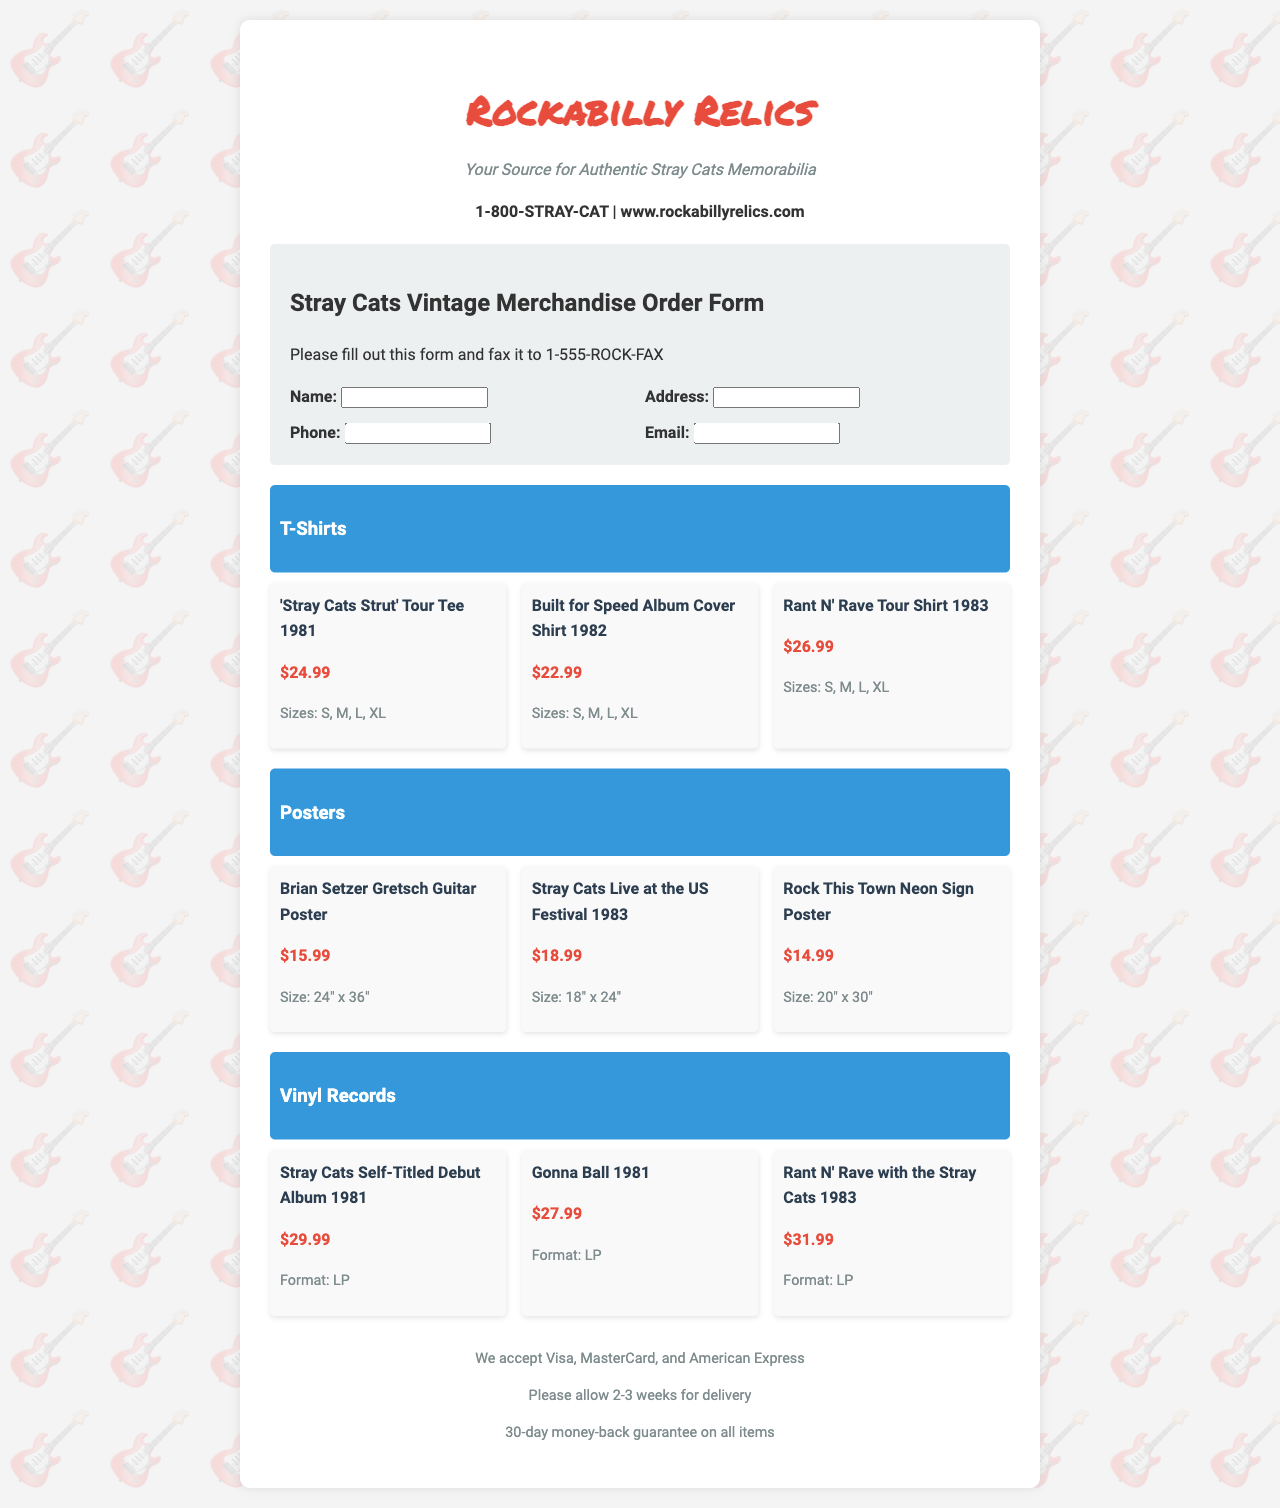What is the fax number to send the order form? The fax number is clearly stated in the document as 1-555-ROCK-FAX.
Answer: 1-555-ROCK-FAX How many types of merchandise are listed in the document? The document includes three categories of merchandise: T-Shirts, Posters, and Vinyl Records.
Answer: Three What is the price of the 'Stray Cats Strut' Tour Tee 1981? The price for the 'Stray Cats Strut' Tour Tee 1981 is listed as $24.99.
Answer: $24.99 What size options are available for the Built for Speed Album Cover Shirt? The shirt offers Size options: S, M, L, XL, as indicated in the document.
Answer: S, M, L, XL What is the size of the Brian Setzer Gretsch Guitar Poster? The size of this poster is stated to be 24" x 36".
Answer: 24" x 36" Which vinyl record has the highest price listed? The greatest price among the vinyl records is for "Rant N' Rave with the Stray Cats 1983," listed at $31.99.
Answer: $31.99 What payment methods are accepted according to the document? The document specifies that Visa, MasterCard, and American Express are accepted as payment methods.
Answer: Visa, MasterCard, and American Express What is the slogan for Rockabilly Relics? The slogan states that they are "Your Source for Authentic Stray Cats Memorabilia."
Answer: Your Source for Authentic Stray Cats Memorabilia How many weeks should one allow for delivery? The document advises to allow 2-3 weeks for delivery.
Answer: 2-3 weeks 